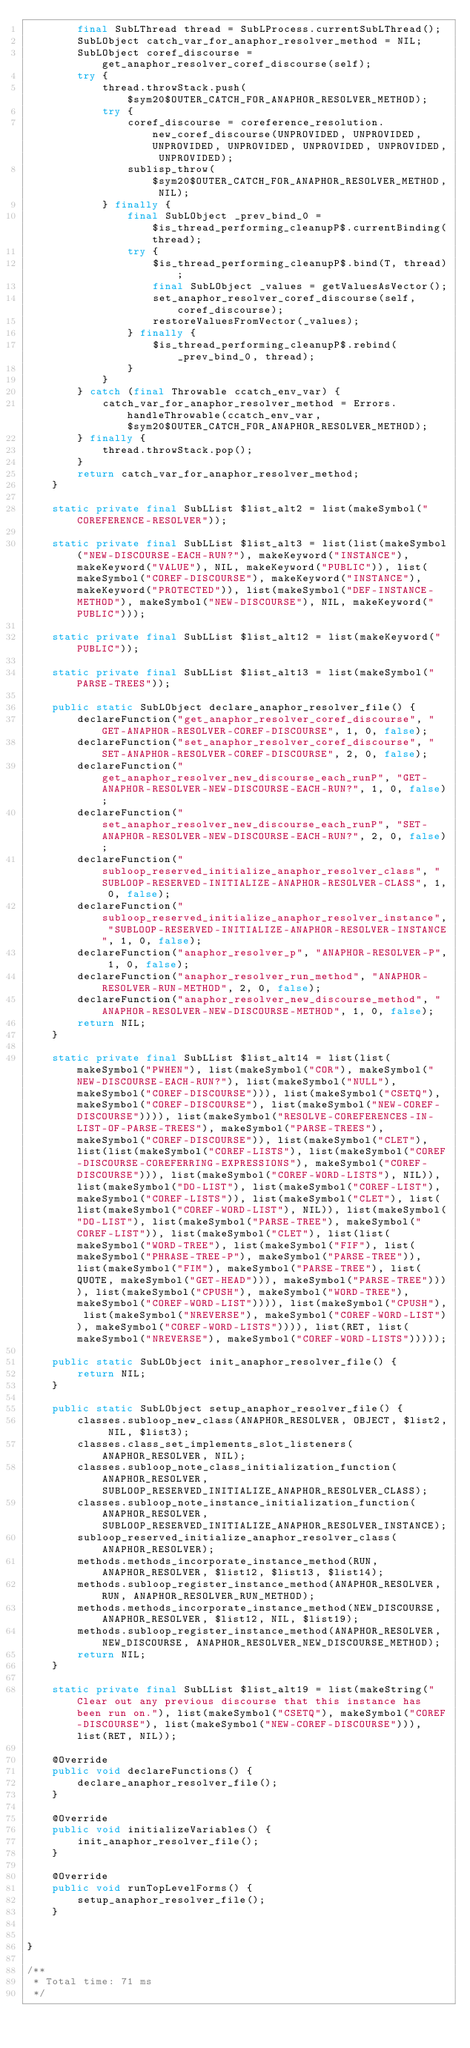Convert code to text. <code><loc_0><loc_0><loc_500><loc_500><_Java_>        final SubLThread thread = SubLProcess.currentSubLThread();
        SubLObject catch_var_for_anaphor_resolver_method = NIL;
        SubLObject coref_discourse = get_anaphor_resolver_coref_discourse(self);
        try {
            thread.throwStack.push($sym20$OUTER_CATCH_FOR_ANAPHOR_RESOLVER_METHOD);
            try {
                coref_discourse = coreference_resolution.new_coref_discourse(UNPROVIDED, UNPROVIDED, UNPROVIDED, UNPROVIDED, UNPROVIDED, UNPROVIDED, UNPROVIDED);
                sublisp_throw($sym20$OUTER_CATCH_FOR_ANAPHOR_RESOLVER_METHOD, NIL);
            } finally {
                final SubLObject _prev_bind_0 = $is_thread_performing_cleanupP$.currentBinding(thread);
                try {
                    $is_thread_performing_cleanupP$.bind(T, thread);
                    final SubLObject _values = getValuesAsVector();
                    set_anaphor_resolver_coref_discourse(self, coref_discourse);
                    restoreValuesFromVector(_values);
                } finally {
                    $is_thread_performing_cleanupP$.rebind(_prev_bind_0, thread);
                }
            }
        } catch (final Throwable ccatch_env_var) {
            catch_var_for_anaphor_resolver_method = Errors.handleThrowable(ccatch_env_var, $sym20$OUTER_CATCH_FOR_ANAPHOR_RESOLVER_METHOD);
        } finally {
            thread.throwStack.pop();
        }
        return catch_var_for_anaphor_resolver_method;
    }

    static private final SubLList $list_alt2 = list(makeSymbol("COREFERENCE-RESOLVER"));

    static private final SubLList $list_alt3 = list(list(makeSymbol("NEW-DISCOURSE-EACH-RUN?"), makeKeyword("INSTANCE"), makeKeyword("VALUE"), NIL, makeKeyword("PUBLIC")), list(makeSymbol("COREF-DISCOURSE"), makeKeyword("INSTANCE"), makeKeyword("PROTECTED")), list(makeSymbol("DEF-INSTANCE-METHOD"), makeSymbol("NEW-DISCOURSE"), NIL, makeKeyword("PUBLIC")));

    static private final SubLList $list_alt12 = list(makeKeyword("PUBLIC"));

    static private final SubLList $list_alt13 = list(makeSymbol("PARSE-TREES"));

    public static SubLObject declare_anaphor_resolver_file() {
        declareFunction("get_anaphor_resolver_coref_discourse", "GET-ANAPHOR-RESOLVER-COREF-DISCOURSE", 1, 0, false);
        declareFunction("set_anaphor_resolver_coref_discourse", "SET-ANAPHOR-RESOLVER-COREF-DISCOURSE", 2, 0, false);
        declareFunction("get_anaphor_resolver_new_discourse_each_runP", "GET-ANAPHOR-RESOLVER-NEW-DISCOURSE-EACH-RUN?", 1, 0, false);
        declareFunction("set_anaphor_resolver_new_discourse_each_runP", "SET-ANAPHOR-RESOLVER-NEW-DISCOURSE-EACH-RUN?", 2, 0, false);
        declareFunction("subloop_reserved_initialize_anaphor_resolver_class", "SUBLOOP-RESERVED-INITIALIZE-ANAPHOR-RESOLVER-CLASS", 1, 0, false);
        declareFunction("subloop_reserved_initialize_anaphor_resolver_instance", "SUBLOOP-RESERVED-INITIALIZE-ANAPHOR-RESOLVER-INSTANCE", 1, 0, false);
        declareFunction("anaphor_resolver_p", "ANAPHOR-RESOLVER-P", 1, 0, false);
        declareFunction("anaphor_resolver_run_method", "ANAPHOR-RESOLVER-RUN-METHOD", 2, 0, false);
        declareFunction("anaphor_resolver_new_discourse_method", "ANAPHOR-RESOLVER-NEW-DISCOURSE-METHOD", 1, 0, false);
        return NIL;
    }

    static private final SubLList $list_alt14 = list(list(makeSymbol("PWHEN"), list(makeSymbol("COR"), makeSymbol("NEW-DISCOURSE-EACH-RUN?"), list(makeSymbol("NULL"), makeSymbol("COREF-DISCOURSE"))), list(makeSymbol("CSETQ"), makeSymbol("COREF-DISCOURSE"), list(makeSymbol("NEW-COREF-DISCOURSE")))), list(makeSymbol("RESOLVE-COREFERENCES-IN-LIST-OF-PARSE-TREES"), makeSymbol("PARSE-TREES"), makeSymbol("COREF-DISCOURSE")), list(makeSymbol("CLET"), list(list(makeSymbol("COREF-LISTS"), list(makeSymbol("COREF-DISCOURSE-COREFERRING-EXPRESSIONS"), makeSymbol("COREF-DISCOURSE"))), list(makeSymbol("COREF-WORD-LISTS"), NIL)), list(makeSymbol("DO-LIST"), list(makeSymbol("COREF-LIST"), makeSymbol("COREF-LISTS")), list(makeSymbol("CLET"), list(list(makeSymbol("COREF-WORD-LIST"), NIL)), list(makeSymbol("DO-LIST"), list(makeSymbol("PARSE-TREE"), makeSymbol("COREF-LIST")), list(makeSymbol("CLET"), list(list(makeSymbol("WORD-TREE"), list(makeSymbol("FIF"), list(makeSymbol("PHRASE-TREE-P"), makeSymbol("PARSE-TREE")), list(makeSymbol("FIM"), makeSymbol("PARSE-TREE"), list(QUOTE, makeSymbol("GET-HEAD"))), makeSymbol("PARSE-TREE")))), list(makeSymbol("CPUSH"), makeSymbol("WORD-TREE"), makeSymbol("COREF-WORD-LIST")))), list(makeSymbol("CPUSH"), list(makeSymbol("NREVERSE"), makeSymbol("COREF-WORD-LIST")), makeSymbol("COREF-WORD-LISTS")))), list(RET, list(makeSymbol("NREVERSE"), makeSymbol("COREF-WORD-LISTS")))));

    public static SubLObject init_anaphor_resolver_file() {
        return NIL;
    }

    public static SubLObject setup_anaphor_resolver_file() {
        classes.subloop_new_class(ANAPHOR_RESOLVER, OBJECT, $list2, NIL, $list3);
        classes.class_set_implements_slot_listeners(ANAPHOR_RESOLVER, NIL);
        classes.subloop_note_class_initialization_function(ANAPHOR_RESOLVER, SUBLOOP_RESERVED_INITIALIZE_ANAPHOR_RESOLVER_CLASS);
        classes.subloop_note_instance_initialization_function(ANAPHOR_RESOLVER, SUBLOOP_RESERVED_INITIALIZE_ANAPHOR_RESOLVER_INSTANCE);
        subloop_reserved_initialize_anaphor_resolver_class(ANAPHOR_RESOLVER);
        methods.methods_incorporate_instance_method(RUN, ANAPHOR_RESOLVER, $list12, $list13, $list14);
        methods.subloop_register_instance_method(ANAPHOR_RESOLVER, RUN, ANAPHOR_RESOLVER_RUN_METHOD);
        methods.methods_incorporate_instance_method(NEW_DISCOURSE, ANAPHOR_RESOLVER, $list12, NIL, $list19);
        methods.subloop_register_instance_method(ANAPHOR_RESOLVER, NEW_DISCOURSE, ANAPHOR_RESOLVER_NEW_DISCOURSE_METHOD);
        return NIL;
    }

    static private final SubLList $list_alt19 = list(makeString("Clear out any previous discourse that this instance has been run on."), list(makeSymbol("CSETQ"), makeSymbol("COREF-DISCOURSE"), list(makeSymbol("NEW-COREF-DISCOURSE"))), list(RET, NIL));

    @Override
    public void declareFunctions() {
        declare_anaphor_resolver_file();
    }

    @Override
    public void initializeVariables() {
        init_anaphor_resolver_file();
    }

    @Override
    public void runTopLevelForms() {
        setup_anaphor_resolver_file();
    }

    
}

/**
 * Total time: 71 ms
 */
</code> 